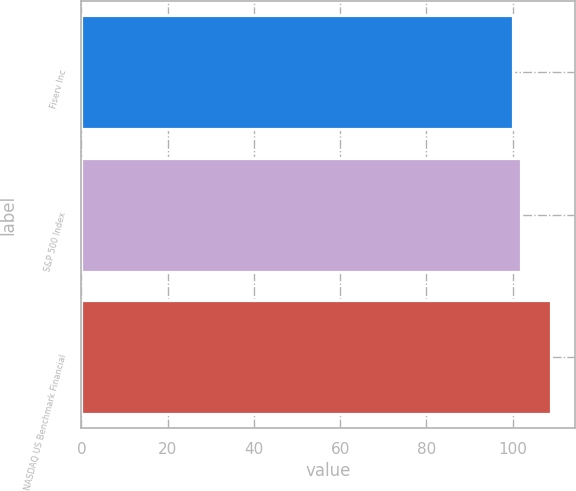Convert chart. <chart><loc_0><loc_0><loc_500><loc_500><bar_chart><fcel>Fiserv Inc<fcel>S&P 500 Index<fcel>NASDAQ US Benchmark Financial<nl><fcel>100<fcel>102<fcel>109<nl></chart> 